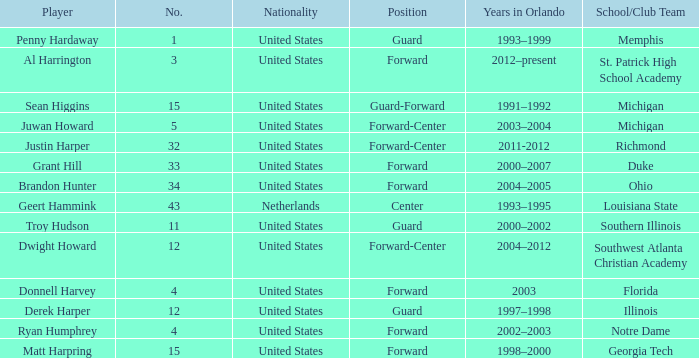What school did Dwight Howard play for Southwest Atlanta Christian Academy. Help me parse the entirety of this table. {'header': ['Player', 'No.', 'Nationality', 'Position', 'Years in Orlando', 'School/Club Team'], 'rows': [['Penny Hardaway', '1', 'United States', 'Guard', '1993–1999', 'Memphis'], ['Al Harrington', '3', 'United States', 'Forward', '2012–present', 'St. Patrick High School Academy'], ['Sean Higgins', '15', 'United States', 'Guard-Forward', '1991–1992', 'Michigan'], ['Juwan Howard', '5', 'United States', 'Forward-Center', '2003–2004', 'Michigan'], ['Justin Harper', '32', 'United States', 'Forward-Center', '2011-2012', 'Richmond'], ['Grant Hill', '33', 'United States', 'Forward', '2000–2007', 'Duke'], ['Brandon Hunter', '34', 'United States', 'Forward', '2004–2005', 'Ohio'], ['Geert Hammink', '43', 'Netherlands', 'Center', '1993–1995', 'Louisiana State'], ['Troy Hudson', '11', 'United States', 'Guard', '2000–2002', 'Southern Illinois'], ['Dwight Howard', '12', 'United States', 'Forward-Center', '2004–2012', 'Southwest Atlanta Christian Academy'], ['Donnell Harvey', '4', 'United States', 'Forward', '2003', 'Florida'], ['Derek Harper', '12', 'United States', 'Guard', '1997–1998', 'Illinois'], ['Ryan Humphrey', '4', 'United States', 'Forward', '2002–2003', 'Notre Dame'], ['Matt Harpring', '15', 'United States', 'Forward', '1998–2000', 'Georgia Tech']]} 